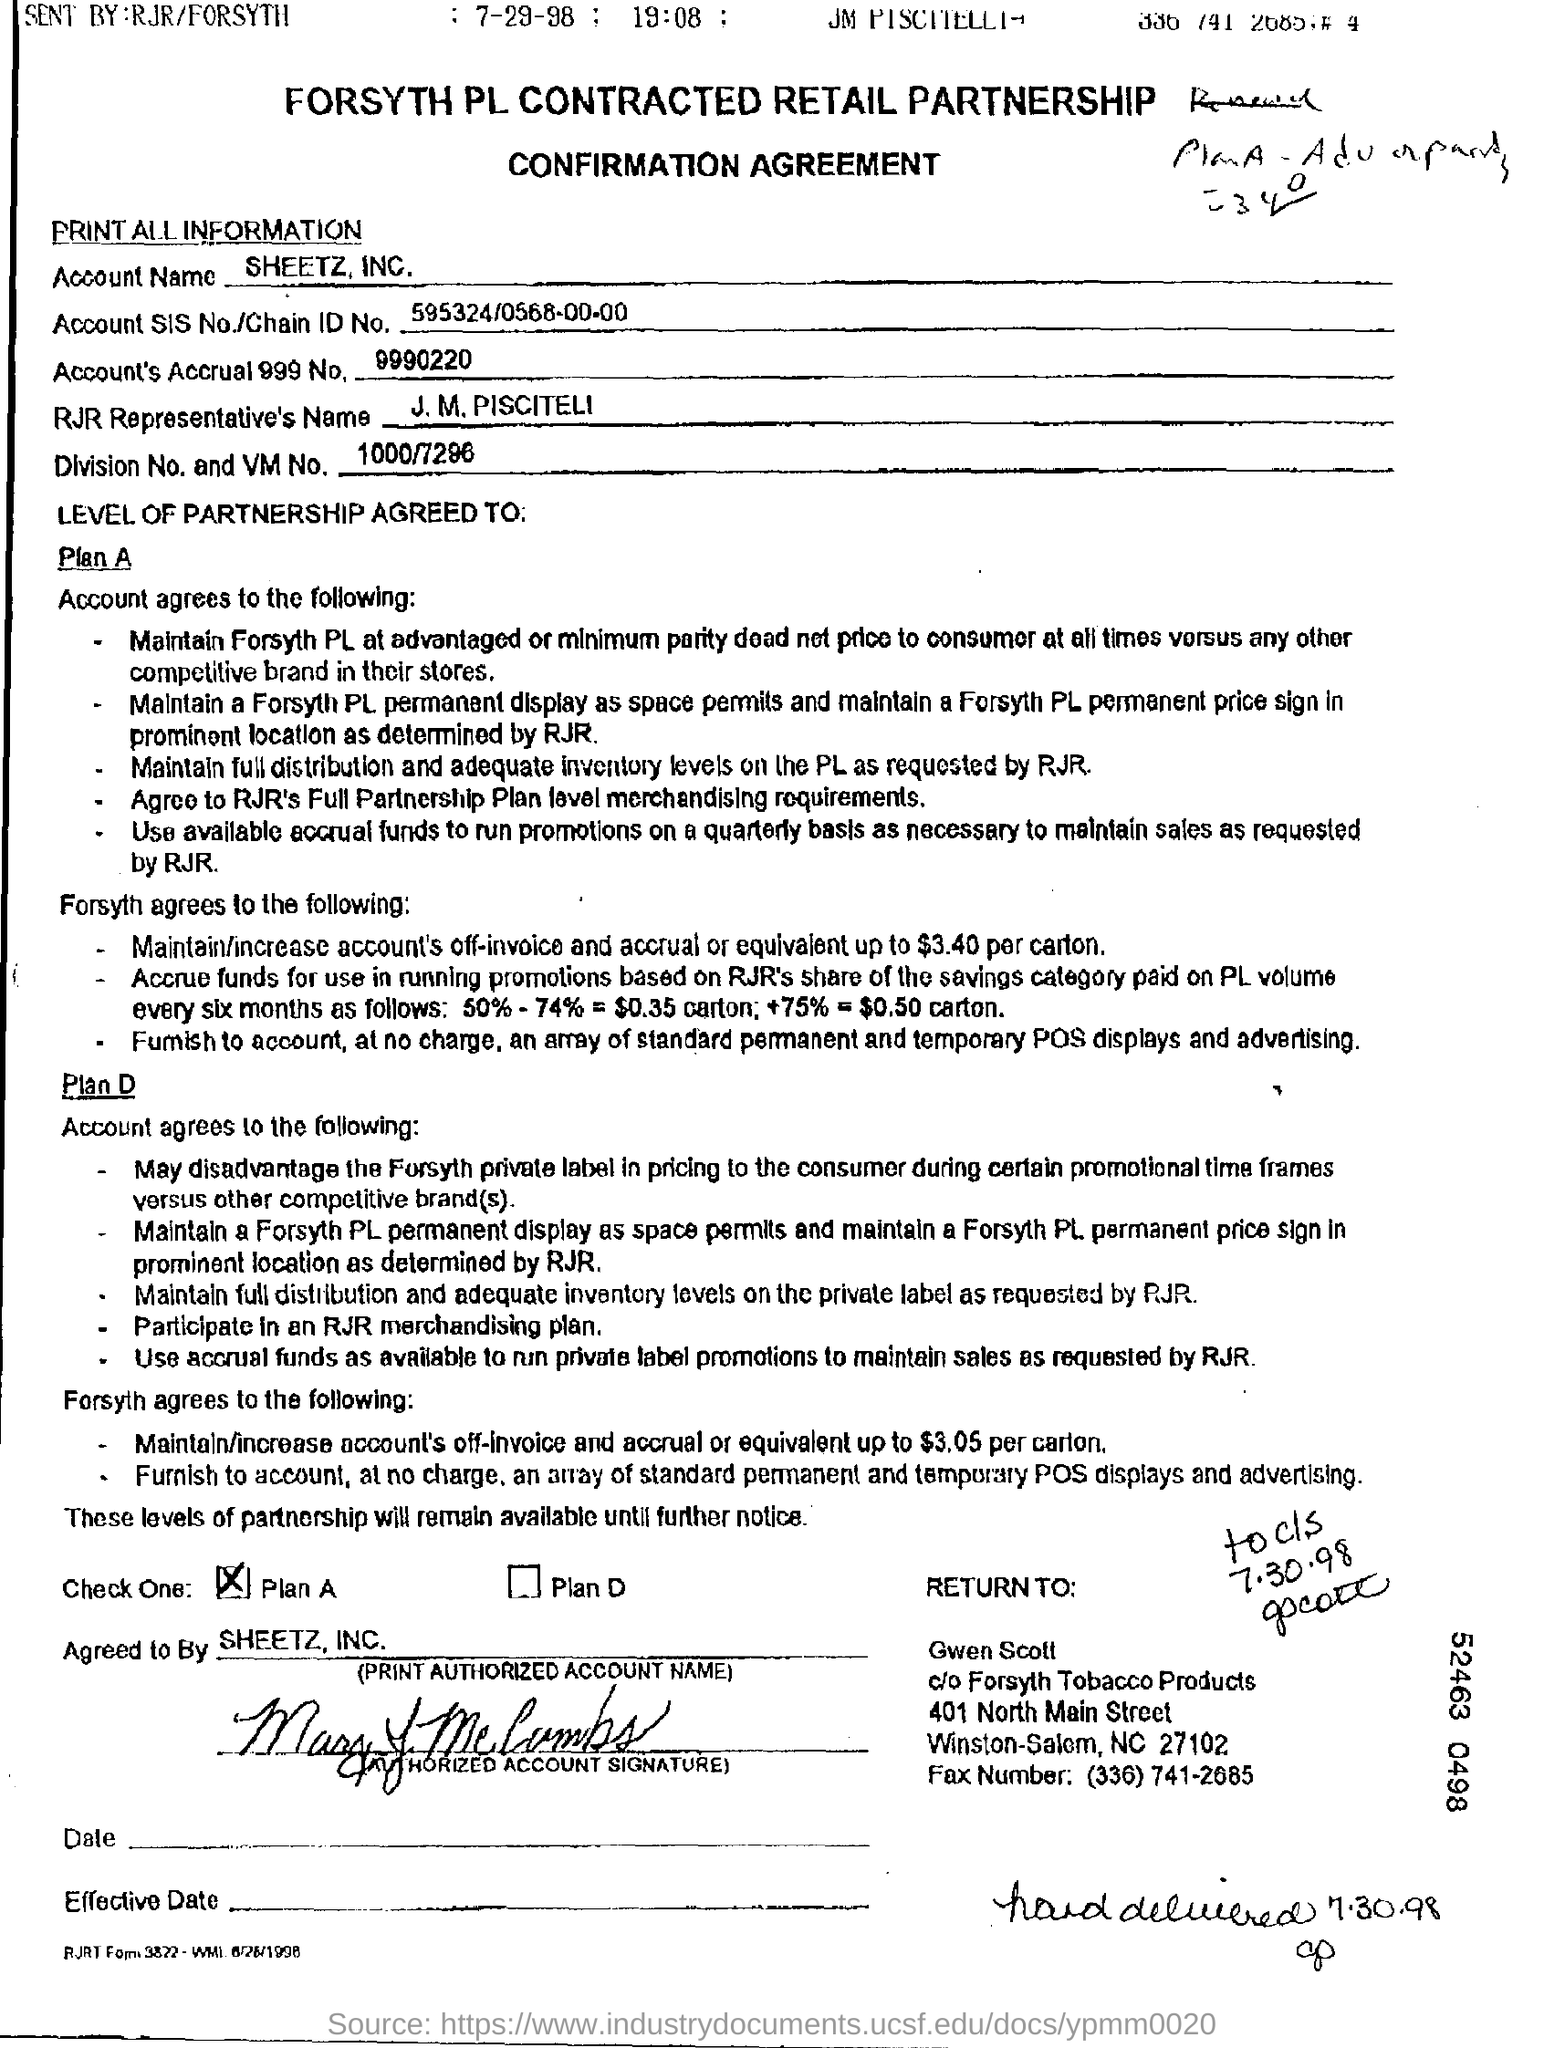What is the account name?
Your answer should be compact. SHEETZ, INC. 